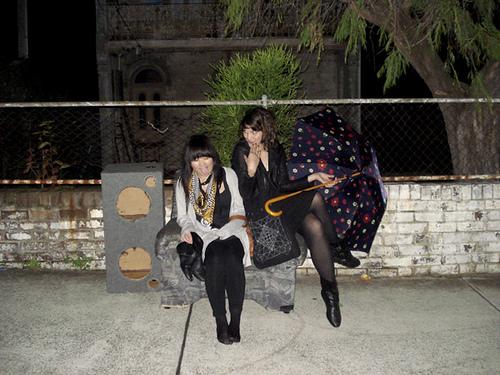Are both people the same gender?
Be succinct. Yes. Is the umbrella opened or closed?
Write a very short answer. Open. What color is the handle of the umbrella?
Be succinct. Brown. 